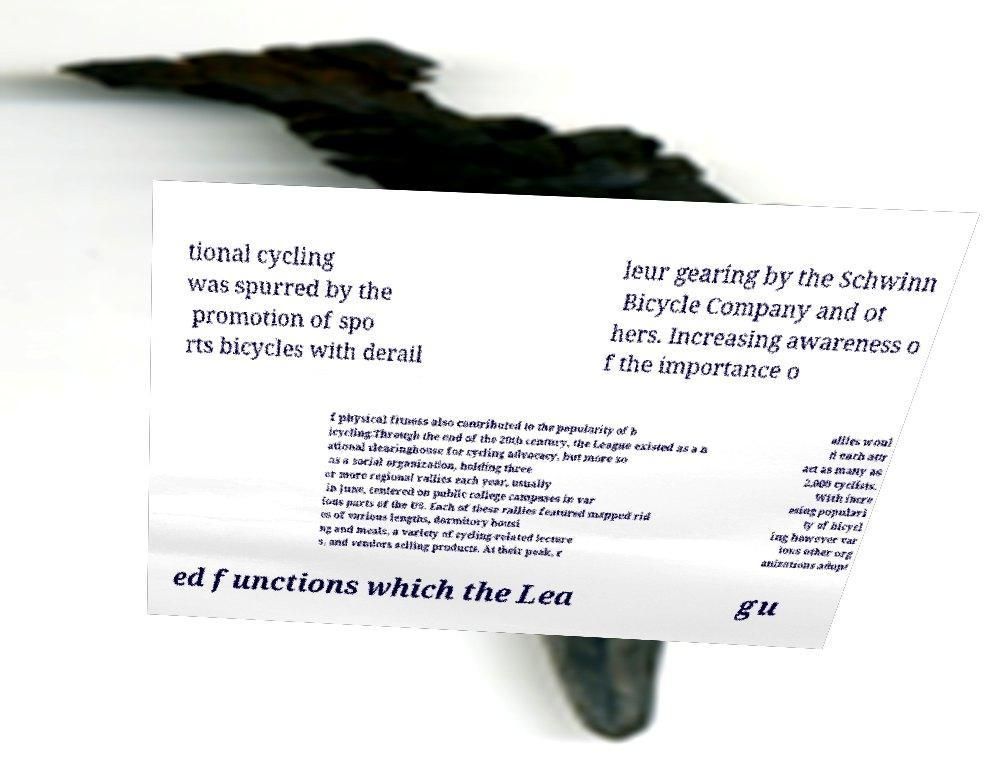Could you extract and type out the text from this image? tional cycling was spurred by the promotion of spo rts bicycles with derail leur gearing by the Schwinn Bicycle Company and ot hers. Increasing awareness o f the importance o f physical fitness also contributed to the popularity of b icycling.Through the end of the 20th century, the League existed as a n ational clearinghouse for cycling advocacy, but more so as a social organization, holding three or more regional rallies each year, usually in June, centered on public college campuses in var ious parts of the US. Each of these rallies featured mapped rid es of various lengths, dormitory housi ng and meals, a variety of cycling-related lecture s, and vendors selling products. At their peak, r allies woul d each attr act as many as 2,000 cyclists. With incre asing populari ty of bicycl ing however var ious other org anizations adopt ed functions which the Lea gu 